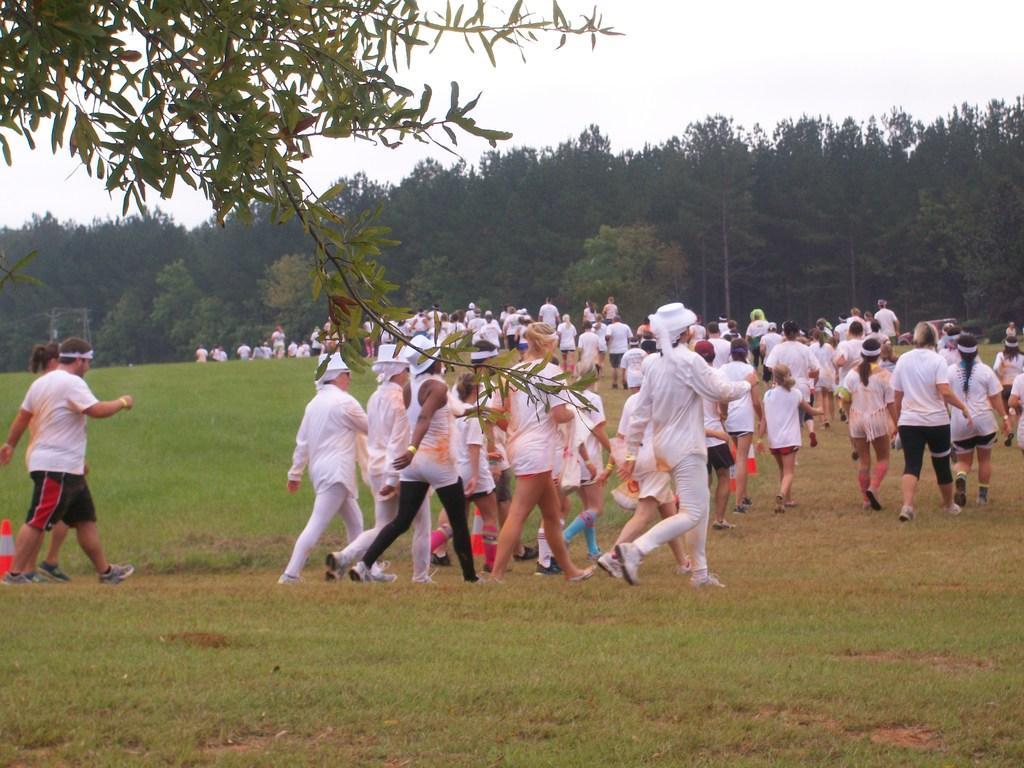How would you summarize this image in a sentence or two? In this picture there are people in the center of the image those who are walking on the grassland and there are trees in the background area of the image. 